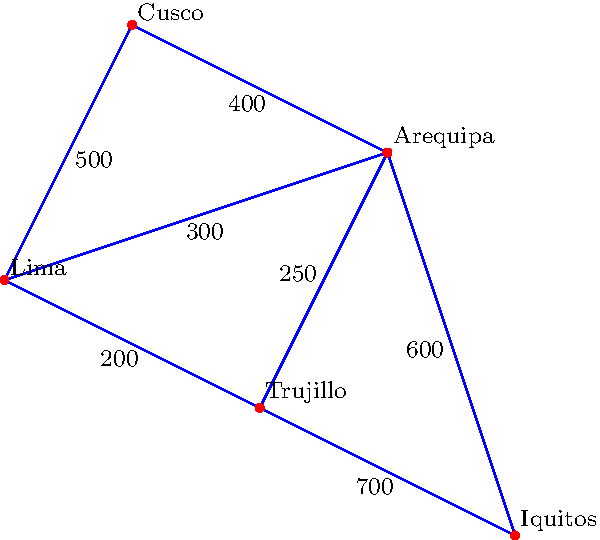In the Peruvian football league, several stadiums are connected by roads as shown in the weighted graph above. The weights represent the distance in kilometers between stadiums. If Club Social Deportivo Estrella Azul needs to travel from Lima to Iquitos for an important match, what is the shortest distance they need to travel? To find the shortest path from Lima to Iquitos, we need to consider all possible routes and calculate their total distances. Let's analyze the possible paths:

1. Lima -> Trujillo -> Iquitos
   Distance = 200 + 700 = 900 km

2. Lima -> Arequipa -> Iquitos
   Distance = 300 + 600 = 900 km

3. Lima -> Cusco -> Arequipa -> Iquitos
   Distance = 500 + 400 + 600 = 1500 km

4. Lima -> Arequipa -> Trujillo -> Iquitos
   Distance = 300 + 250 + 700 = 1250 km

5. Lima -> Trujillo -> Arequipa -> Iquitos
   Distance = 200 + 250 + 600 = 1050 km

Comparing all these distances, we can see that there are two shortest paths with equal distance:
1. Lima -> Trujillo -> Iquitos (900 km)
2. Lima -> Arequipa -> Iquitos (900 km)

Therefore, the shortest distance Club Social Deportivo Estrella Azul needs to travel from Lima to Iquitos is 900 km.
Answer: 900 km 